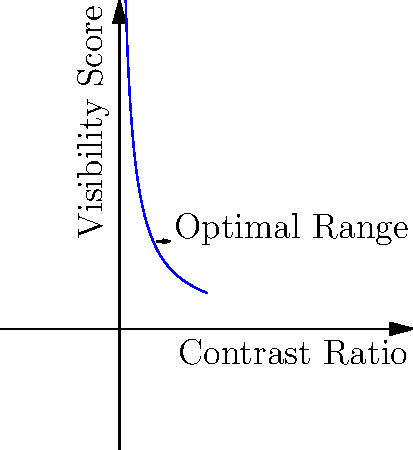Based on the graph showing the relationship between contrast ratio and visibility score for business card design, what is the minimum contrast ratio required to achieve optimal readability while maintaining an eye-catching appearance? To determine the ideal color contrast ratio for a business card, we need to analyze the graph:

1. The x-axis represents the contrast ratio, while the y-axis shows the visibility score.
2. The curve illustrates that as the contrast ratio increases, the visibility score also increases, but at a diminishing rate.
3. We can observe that the curve starts to level off around a contrast ratio of 3:1 to 4:1.
4. The "Optimal Range" arrow points to this area on the graph.
5. In web design, WCAG 2.0 guidelines recommend a minimum contrast ratio of 4.5:1 for normal text to ensure readability for most users.
6. However, for larger text or artistic designs like business cards, a slightly lower ratio can still provide good readability while allowing for more creative color choices.
7. Considering the graph and the need for eye-catching design, we can conclude that a minimum contrast ratio of 3:1 would provide a good balance between readability and visual appeal.

This ratio ensures that the text is clearly visible against the background while still allowing for vibrant and unique color combinations that can make the business card stand out.
Answer: 3:1 